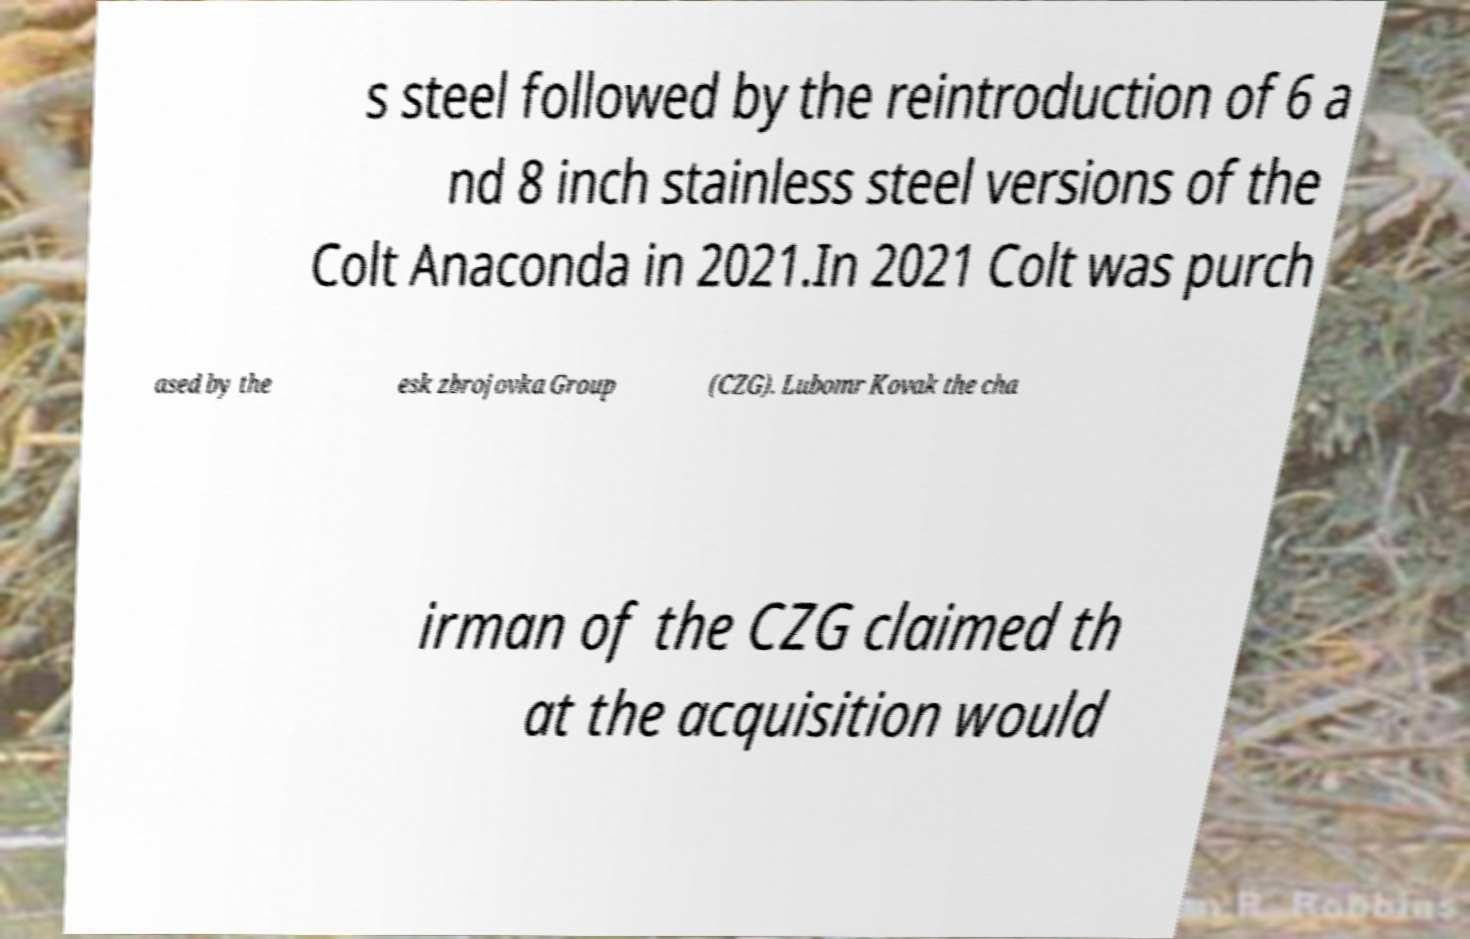What messages or text are displayed in this image? I need them in a readable, typed format. s steel followed by the reintroduction of 6 a nd 8 inch stainless steel versions of the Colt Anaconda in 2021.In 2021 Colt was purch ased by the esk zbrojovka Group (CZG). Lubomr Kovak the cha irman of the CZG claimed th at the acquisition would 